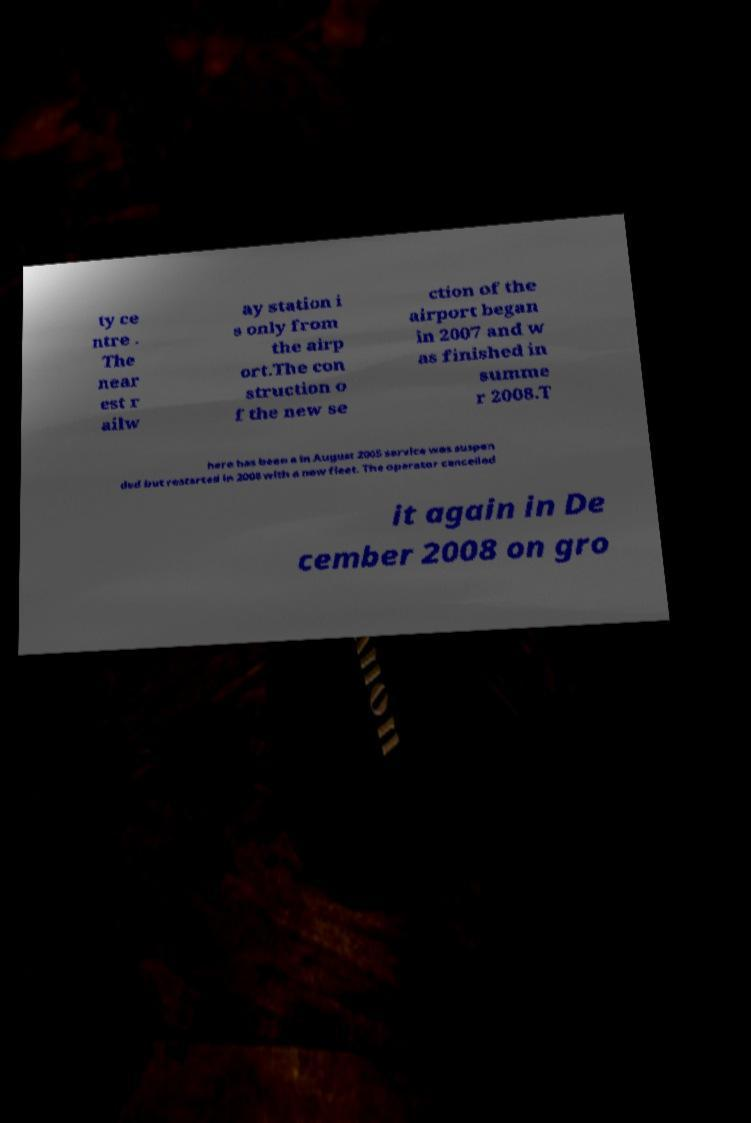Please identify and transcribe the text found in this image. ty ce ntre . The near est r ailw ay station i s only from the airp ort.The con struction o f the new se ction of the airport began in 2007 and w as finished in summe r 2008.T here has been a in August 2005 service was suspen ded but restarted in 2008 with a new fleet. The operator cancelled it again in De cember 2008 on gro 